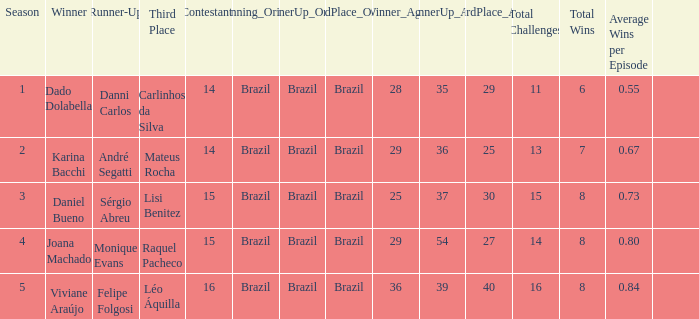Who finished in third place when the winner was Karina Bacchi?  Mateus Rocha. I'm looking to parse the entire table for insights. Could you assist me with that? {'header': ['Season', 'Winner', 'Runner-Up', 'Third Place', 'Contestants', 'Winning_Origin', 'RunnerUp_Origin', 'ThirdPlace_Origin', 'Winner_Age', 'RunnerUp_Age', 'ThirdPlace_Age', 'Total Challenges', 'Total Wins', 'Average Wins per Episode', ''], 'rows': [['1', 'Dado Dolabella', 'Danni Carlos', 'Carlinhos da Silva', '14', 'Brazil', 'Brazil', 'Brazil', '28', '35', '29', '11', '6', '0.55', ''], ['2', 'Karina Bacchi', 'André Segatti', 'Mateus Rocha', '14', 'Brazil', 'Brazil', 'Brazil', '29', '36', '25', '13', '7', '0.67', ''], ['3', 'Daniel Bueno', 'Sérgio Abreu', 'Lisi Benitez', '15', 'Brazil', 'Brazil', 'Brazil', '25', '37', '30', '15', '8', '0.73', ''], ['4', 'Joana Machado', 'Monique Evans', 'Raquel Pacheco', '15', 'Brazil', 'Brazil', 'Brazil', '29', '54', '27', '14', '8', '0.80', ''], ['5', 'Viviane Araújo', 'Felipe Folgosi', 'Léo Áquilla', '16', 'Brazil', 'Brazil', 'Brazil', '36', '39', '40', '16', '8', '0.84', '']]} 